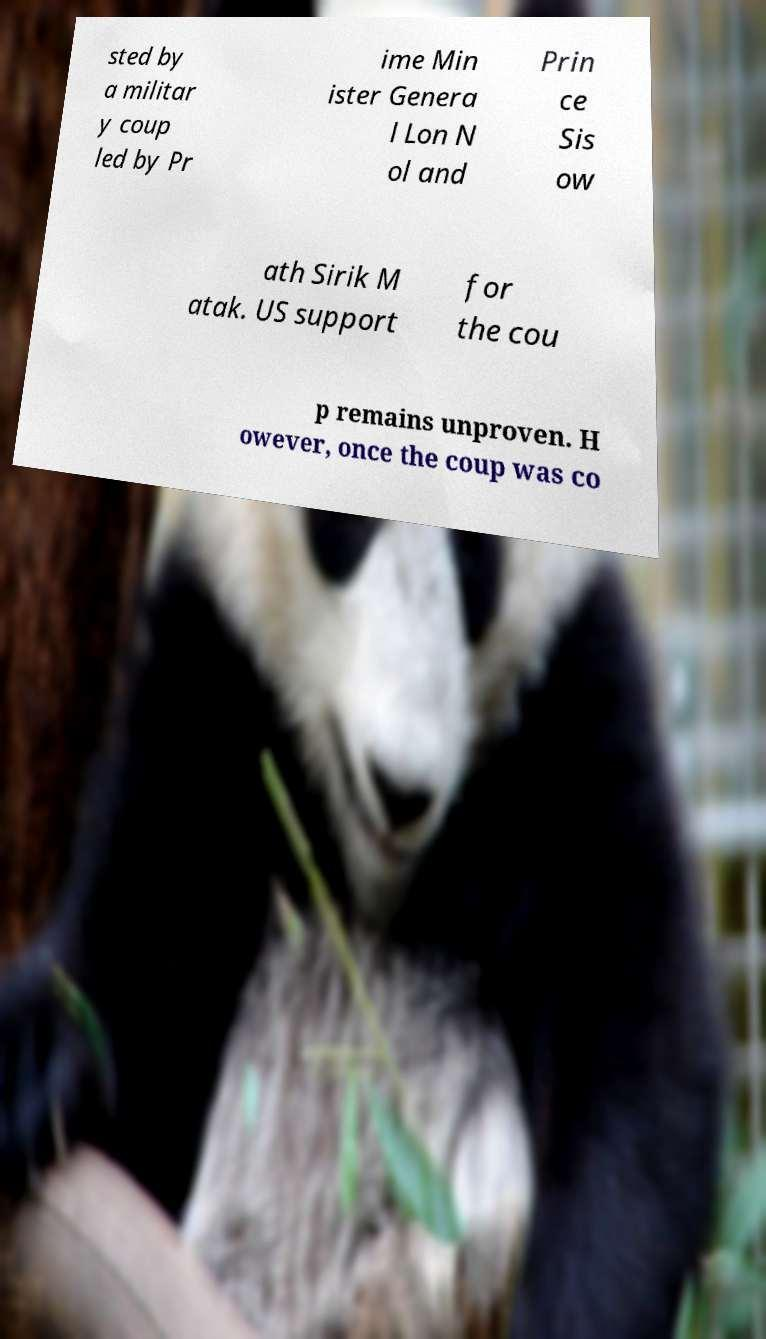Could you assist in decoding the text presented in this image and type it out clearly? sted by a militar y coup led by Pr ime Min ister Genera l Lon N ol and Prin ce Sis ow ath Sirik M atak. US support for the cou p remains unproven. H owever, once the coup was co 